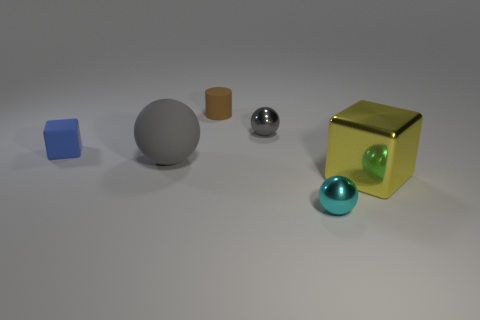How many gray balls must be subtracted to get 1 gray balls? 1 Add 4 tiny cyan balls. How many objects exist? 10 Subtract all cylinders. How many objects are left? 5 Subtract 0 green cylinders. How many objects are left? 6 Subtract all gray rubber spheres. Subtract all large gray things. How many objects are left? 4 Add 6 yellow metallic cubes. How many yellow metallic cubes are left? 7 Add 6 tiny brown objects. How many tiny brown objects exist? 7 